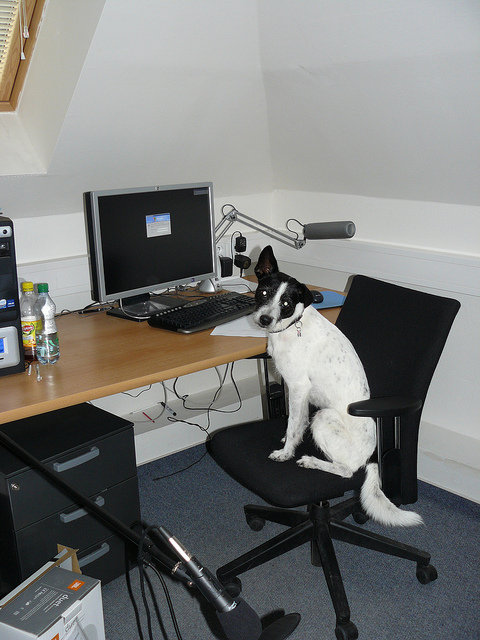<image>What breed of dog is this? I don't know what breed the dog is. It could be a terrier, a jack russell, a mutt, a bull, or a poodle. What breed of dog is this? I am not sure what breed of dog this is. It could be terrier, mutt, jack russell, or poodle. 